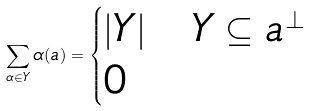Convert formula to latex. <formula><loc_0><loc_0><loc_500><loc_500>\sum _ { \alpha \in Y } \alpha ( a ) = \begin{cases} | Y | & Y \subseteq a ^ { \perp } \\ 0 & \end{cases}</formula> 